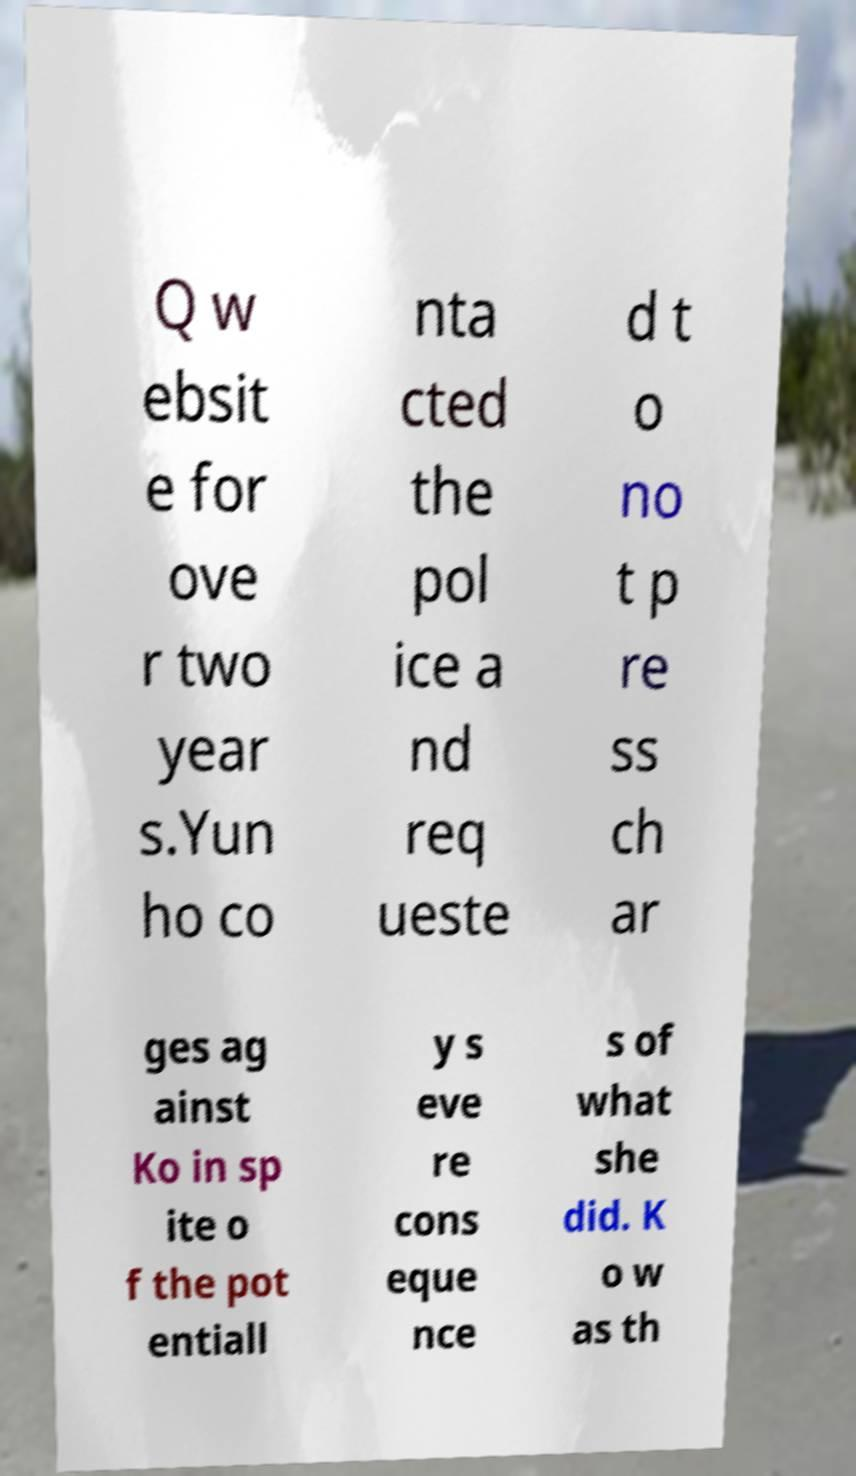Could you extract and type out the text from this image? Q w ebsit e for ove r two year s.Yun ho co nta cted the pol ice a nd req ueste d t o no t p re ss ch ar ges ag ainst Ko in sp ite o f the pot entiall y s eve re cons eque nce s of what she did. K o w as th 